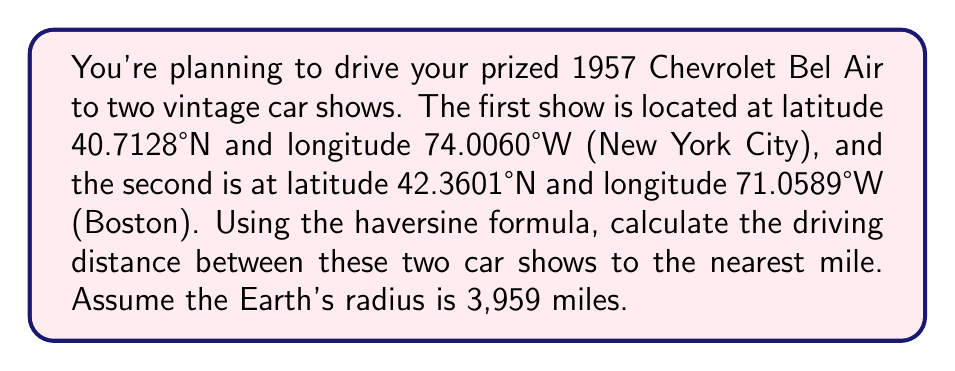Provide a solution to this math problem. To solve this problem, we'll use the haversine formula:

$$a = \sin^2(\frac{\Delta\phi}{2}) + \cos\phi_1 \cdot \cos\phi_2 \cdot \sin^2(\frac{\Delta\lambda}{2})$$
$$c = 2 \cdot \arctan2(\sqrt{a}, \sqrt{1-a})$$
$$d = R \cdot c$$

Where:
$\phi$ is latitude, $\lambda$ is longitude, $R$ is Earth's radius (3,959 miles)

Step 1: Convert latitudes and longitudes from degrees to radians:
$\phi_1 = 40.7128° \cdot \frac{\pi}{180} = 0.7102$ rad
$\lambda_1 = -74.0060° \cdot \frac{\pi}{180} = -1.2915$ rad
$\phi_2 = 42.3601° \cdot \frac{\pi}{180} = 0.7392$ rad
$\lambda_2 = -71.0589° \cdot \frac{\pi}{180} = -1.2401$ rad

Step 2: Calculate differences:
$\Delta\phi = \phi_2 - \phi_1 = 0.7392 - 0.7102 = 0.0290$ rad
$\Delta\lambda = \lambda_2 - \lambda_1 = -1.2401 - (-1.2915) = 0.0514$ rad

Step 3: Calculate $a$:
$$a = \sin^2(\frac{0.0290}{2}) + \cos(0.7102) \cdot \cos(0.7392) \cdot \sin^2(\frac{0.0514}{2}) = 0.0002$$

Step 4: Calculate $c$:
$$c = 2 \cdot \arctan2(\sqrt{0.0002}, \sqrt{1-0.0002}) = 0.0281$$

Step 5: Calculate distance $d$:
$$d = 3959 \cdot 0.0281 = 111.2479\text{ miles}$$

Step 6: Round to the nearest mile:
$d \approx 111\text{ miles}$
Answer: 111 miles 